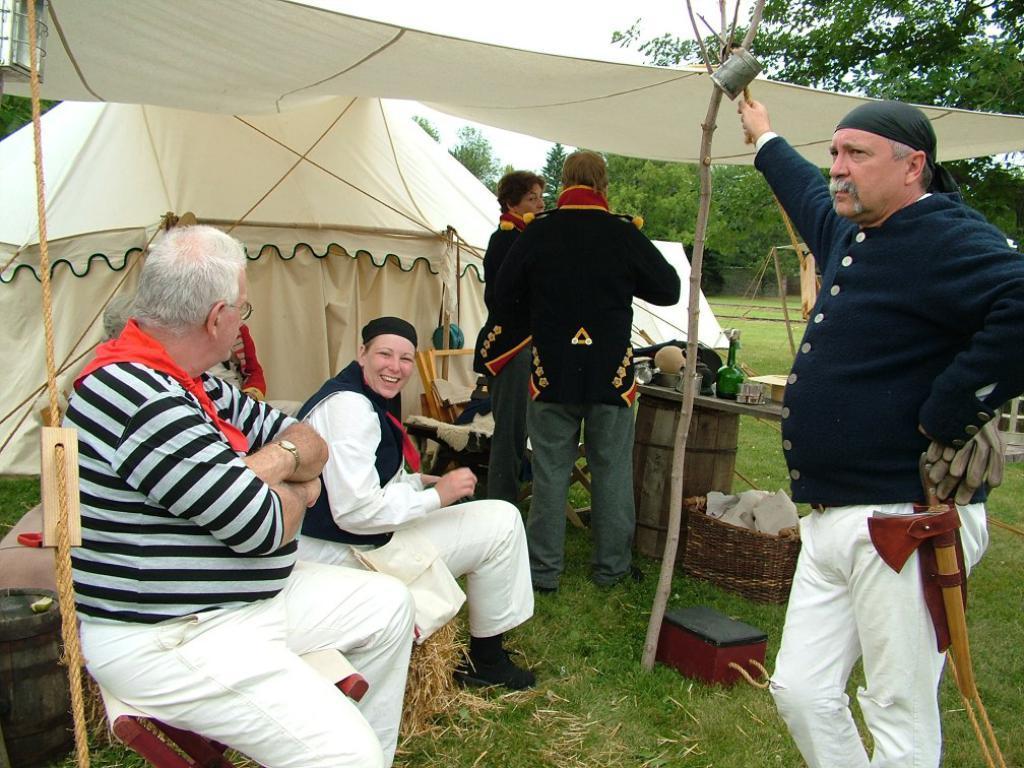Can you describe this image briefly? In this picture, we see people are sitting under the white tent. We even see two men are standing under the tent. In front of them, we see a table on which glass bottle, glasses and some other things are placed. Beside them, we see a chair. Beside the table, we see a basket. The man on the right side is standing and he has an axe. At the bottom of the picture, we see the grass. Behind them, we see a white tent. There are trees in the background. 